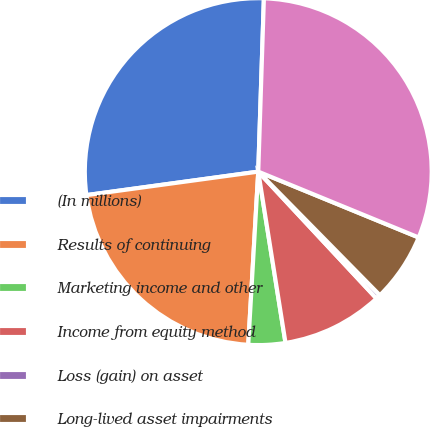Convert chart to OTSL. <chart><loc_0><loc_0><loc_500><loc_500><pie_chart><fcel>(In millions)<fcel>Results of continuing<fcel>Marketing income and other<fcel>Income from equity method<fcel>Loss (gain) on asset<fcel>Long-lived asset impairments<fcel>Segment income<nl><fcel>27.68%<fcel>21.92%<fcel>3.43%<fcel>9.43%<fcel>0.43%<fcel>6.43%<fcel>30.68%<nl></chart> 